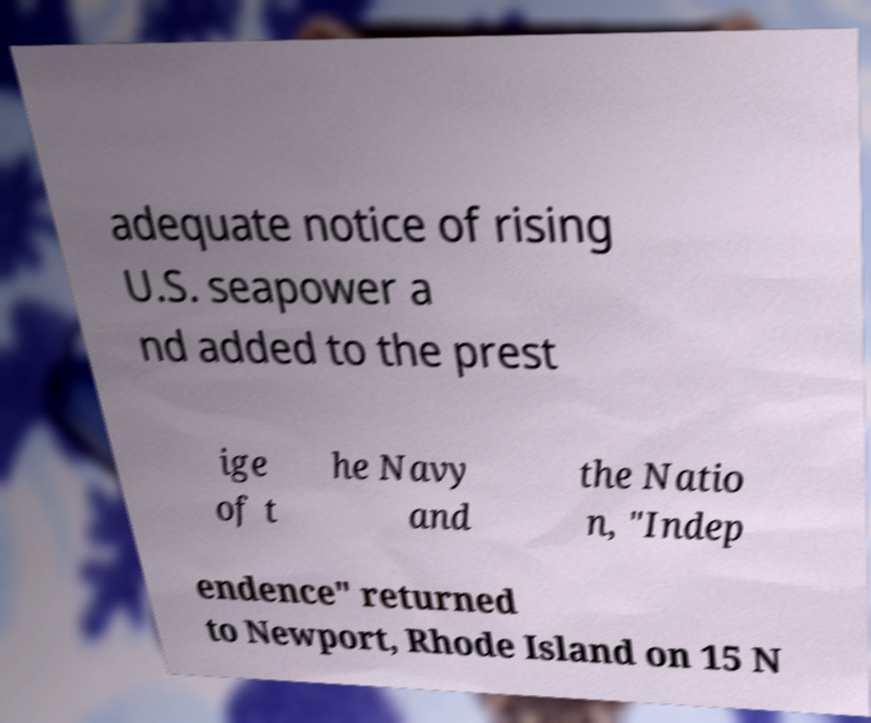Can you read and provide the text displayed in the image?This photo seems to have some interesting text. Can you extract and type it out for me? adequate notice of rising U.S. seapower a nd added to the prest ige of t he Navy and the Natio n, "Indep endence" returned to Newport, Rhode Island on 15 N 